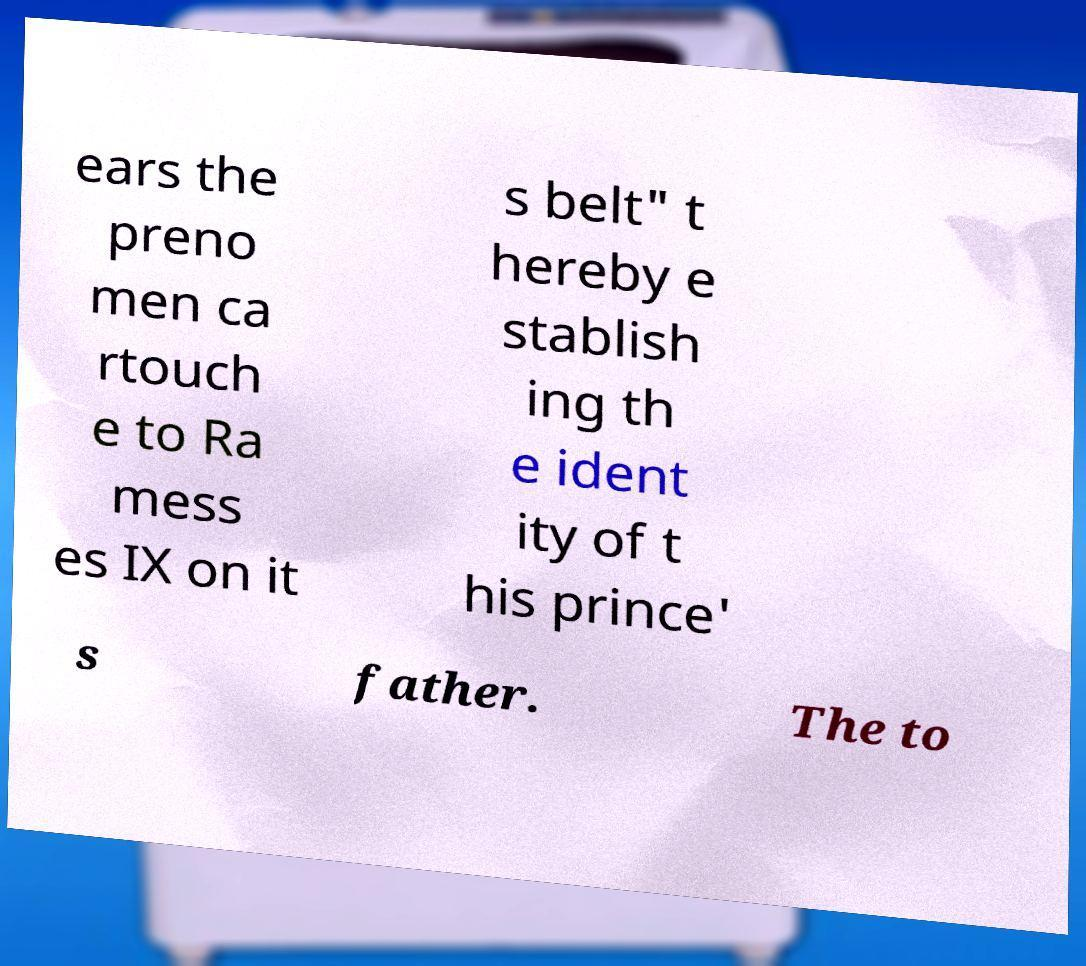Please read and relay the text visible in this image. What does it say? ears the preno men ca rtouch e to Ra mess es IX on it s belt" t hereby e stablish ing th e ident ity of t his prince' s father. The to 